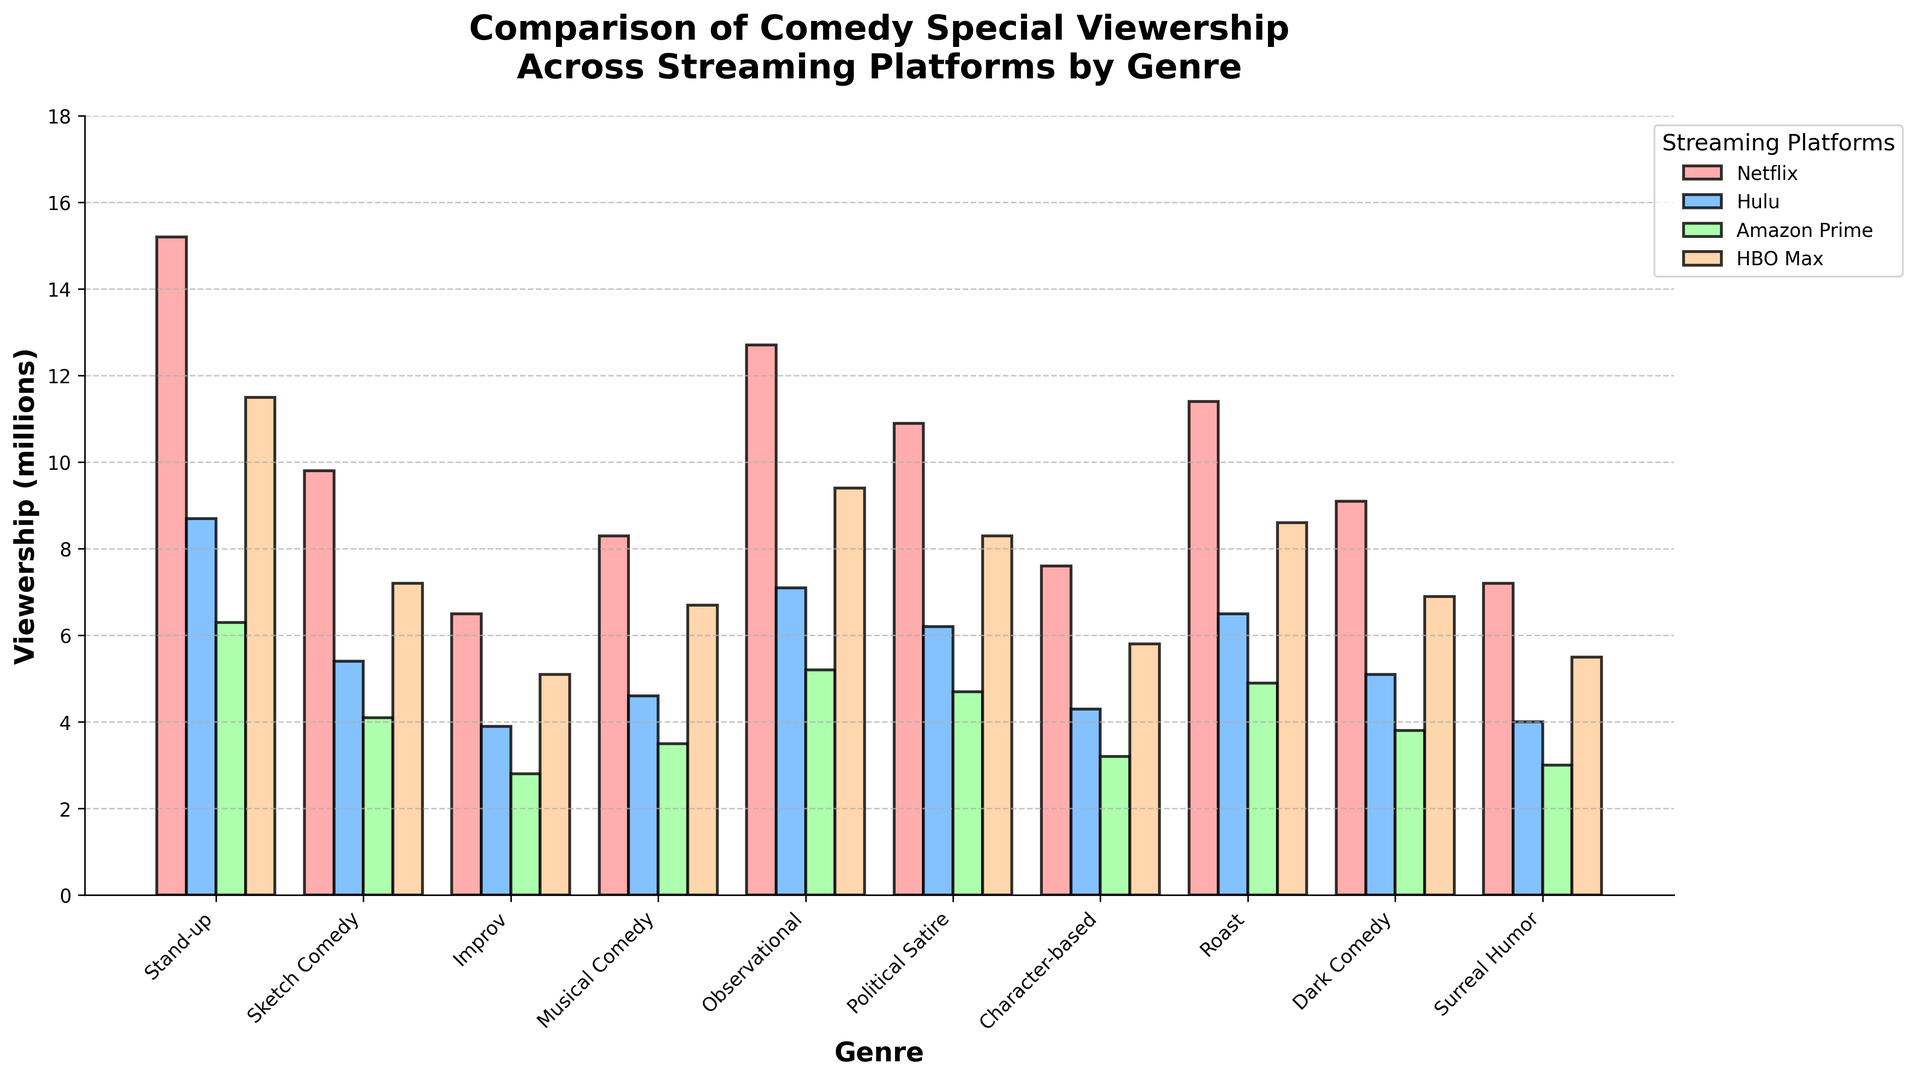What is the viewership for Stand-up comedy on Netflix and Hulu combined? To find the combined viewership, add the viewership numbers for Stand-up comedy on Netflix and Hulu: 15.2 (Netflix) + 8.7 (Hulu) = 23.9 million.
Answer: 23.9 million Which streaming platform has the highest viewership for the Sketch Comedy genre? Compare the viewership for Sketch Comedy across all platforms. The values are 9.8 (Netflix), 5.4 (Hulu), 4.1 (Amazon Prime), and 7.2 (HBO Max). The highest value is 9.8 million on Netflix.
Answer: Netflix Between Amazon Prime and HBO Max, which platform has a higher average viewership across all genres? Calculate the average viewership for each platform. For Amazon Prime: (6.3 + 4.1 + 2.8 + 3.5 + 5.2 + 4.7 + 3.2 + 4.9 + 3.8 + 3.0) / 10 = 4.25. For HBO Max: (11.5 + 7.2 + 5.1 + 6.7 + 9.4 + 8.3 + 5.8 + 8.6 + 6.9 + 5.5) / 10 = 7.5. HBO Max has the higher average viewership.
Answer: HBO Max What is the difference in viewership between Political Satire and Dark Comedy on Netflix? Subtract the viewership for Dark Comedy from Political Satire on Netflix: 10.9 - 9.1 = 1.8 million.
Answer: 1.8 million Which genre has the lowest viewership on Hulu, and what is that value? Identify the lowest viewership value for Hulu across all genres. The values are 8.7, 5.4, 3.9, 4.6, 7.1, 6.2, 4.3, 6.5, 5.1, and 4.0. The lowest is for Improv with 3.9 million.
Answer: Improv, 3.9 million What is the color of the bars representing Hulu's viewership? Look at the legend indicating the color for Hulu. The color is light blue.
Answer: Light blue What is the average viewership for Musical Comedy across all platforms? To find the average, sum the viewership for Musical Comedy across all platforms and divide by the number of platforms: (8.3 + 4.6 + 3.5 + 6.7) / 4 = 23.1 / 4 = 5.775 million.
Answer: 5.775 million How does HBO Max's viewership for Roast compare to Netflix's viewership for the same genre? Compare the viewership values for Roast on both platforms. HBO Max has 8.6 million and Netflix has 11.4 million. Netflix has higher viewership for Roast.
Answer: Netflix Which genre has the most consistent viewership across all platforms (i.e., smallest difference between highest and lowest viewership)? Calculate the difference between the highest and lowest viewership for each genre across all platforms, then identify the smallest difference. For example, Stand-up: (15.2 - 6.3 = 8.9); Sketch Comedy: (9.8 - 4.1 = 5.7); ... Musical Comedy: (8.3 - 3.5 = 4.8). The smallest difference is for Sketch Comedy.
Answer: Sketch Comedy 